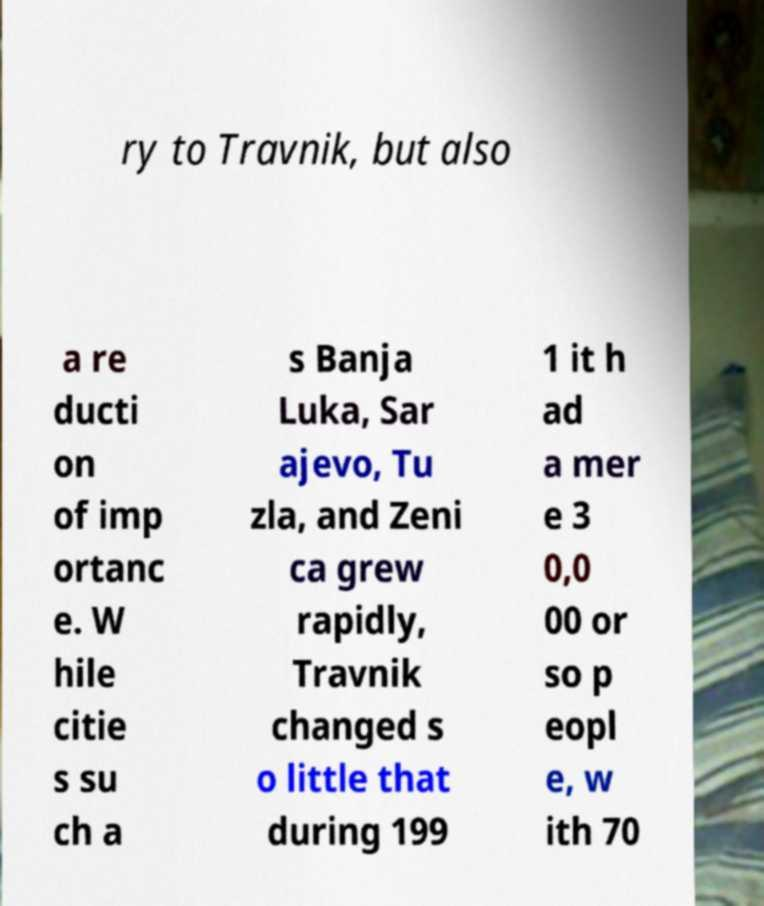Can you read and provide the text displayed in the image?This photo seems to have some interesting text. Can you extract and type it out for me? ry to Travnik, but also a re ducti on of imp ortanc e. W hile citie s su ch a s Banja Luka, Sar ajevo, Tu zla, and Zeni ca grew rapidly, Travnik changed s o little that during 199 1 it h ad a mer e 3 0,0 00 or so p eopl e, w ith 70 